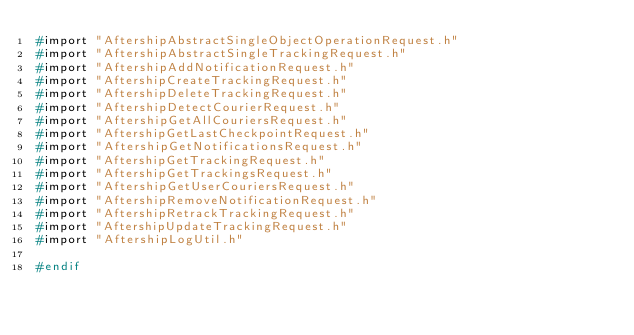<code> <loc_0><loc_0><loc_500><loc_500><_C_>#import "AftershipAbstractSingleObjectOperationRequest.h"
#import "AftershipAbstractSingleTrackingRequest.h"
#import "AftershipAddNotificationRequest.h"
#import "AftershipCreateTrackingRequest.h"
#import "AftershipDeleteTrackingRequest.h"
#import "AftershipDetectCourierRequest.h"
#import "AftershipGetAllCouriersRequest.h"
#import "AftershipGetLastCheckpointRequest.h"
#import "AftershipGetNotificationsRequest.h"
#import "AftershipGetTrackingRequest.h"
#import "AftershipGetTrackingsRequest.h"
#import "AftershipGetUserCouriersRequest.h"
#import "AftershipRemoveNotificationRequest.h"
#import "AftershipRetrackTrackingRequest.h"
#import "AftershipUpdateTrackingRequest.h"
#import "AftershipLogUtil.h"

#endif</code> 